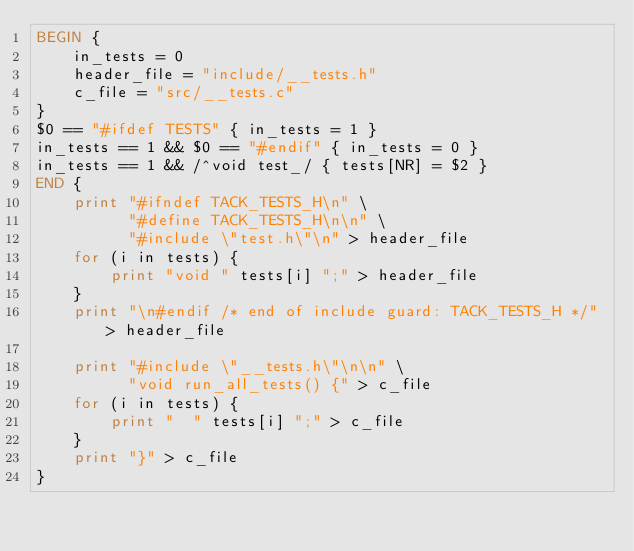<code> <loc_0><loc_0><loc_500><loc_500><_Awk_>BEGIN {
    in_tests = 0
    header_file = "include/__tests.h"
    c_file = "src/__tests.c"
}
$0 == "#ifdef TESTS" { in_tests = 1 }
in_tests == 1 && $0 == "#endif" { in_tests = 0 }
in_tests == 1 && /^void test_/ { tests[NR] = $2 }
END {
    print "#ifndef TACK_TESTS_H\n" \
          "#define TACK_TESTS_H\n\n" \
          "#include \"test.h\"\n" > header_file
    for (i in tests) {
        print "void " tests[i] ";" > header_file
    }
    print "\n#endif /* end of include guard: TACK_TESTS_H */" > header_file

    print "#include \"__tests.h\"\n\n" \
          "void run_all_tests() {" > c_file
    for (i in tests) {
        print "  " tests[i] ";" > c_file
    }
    print "}" > c_file
}
</code> 